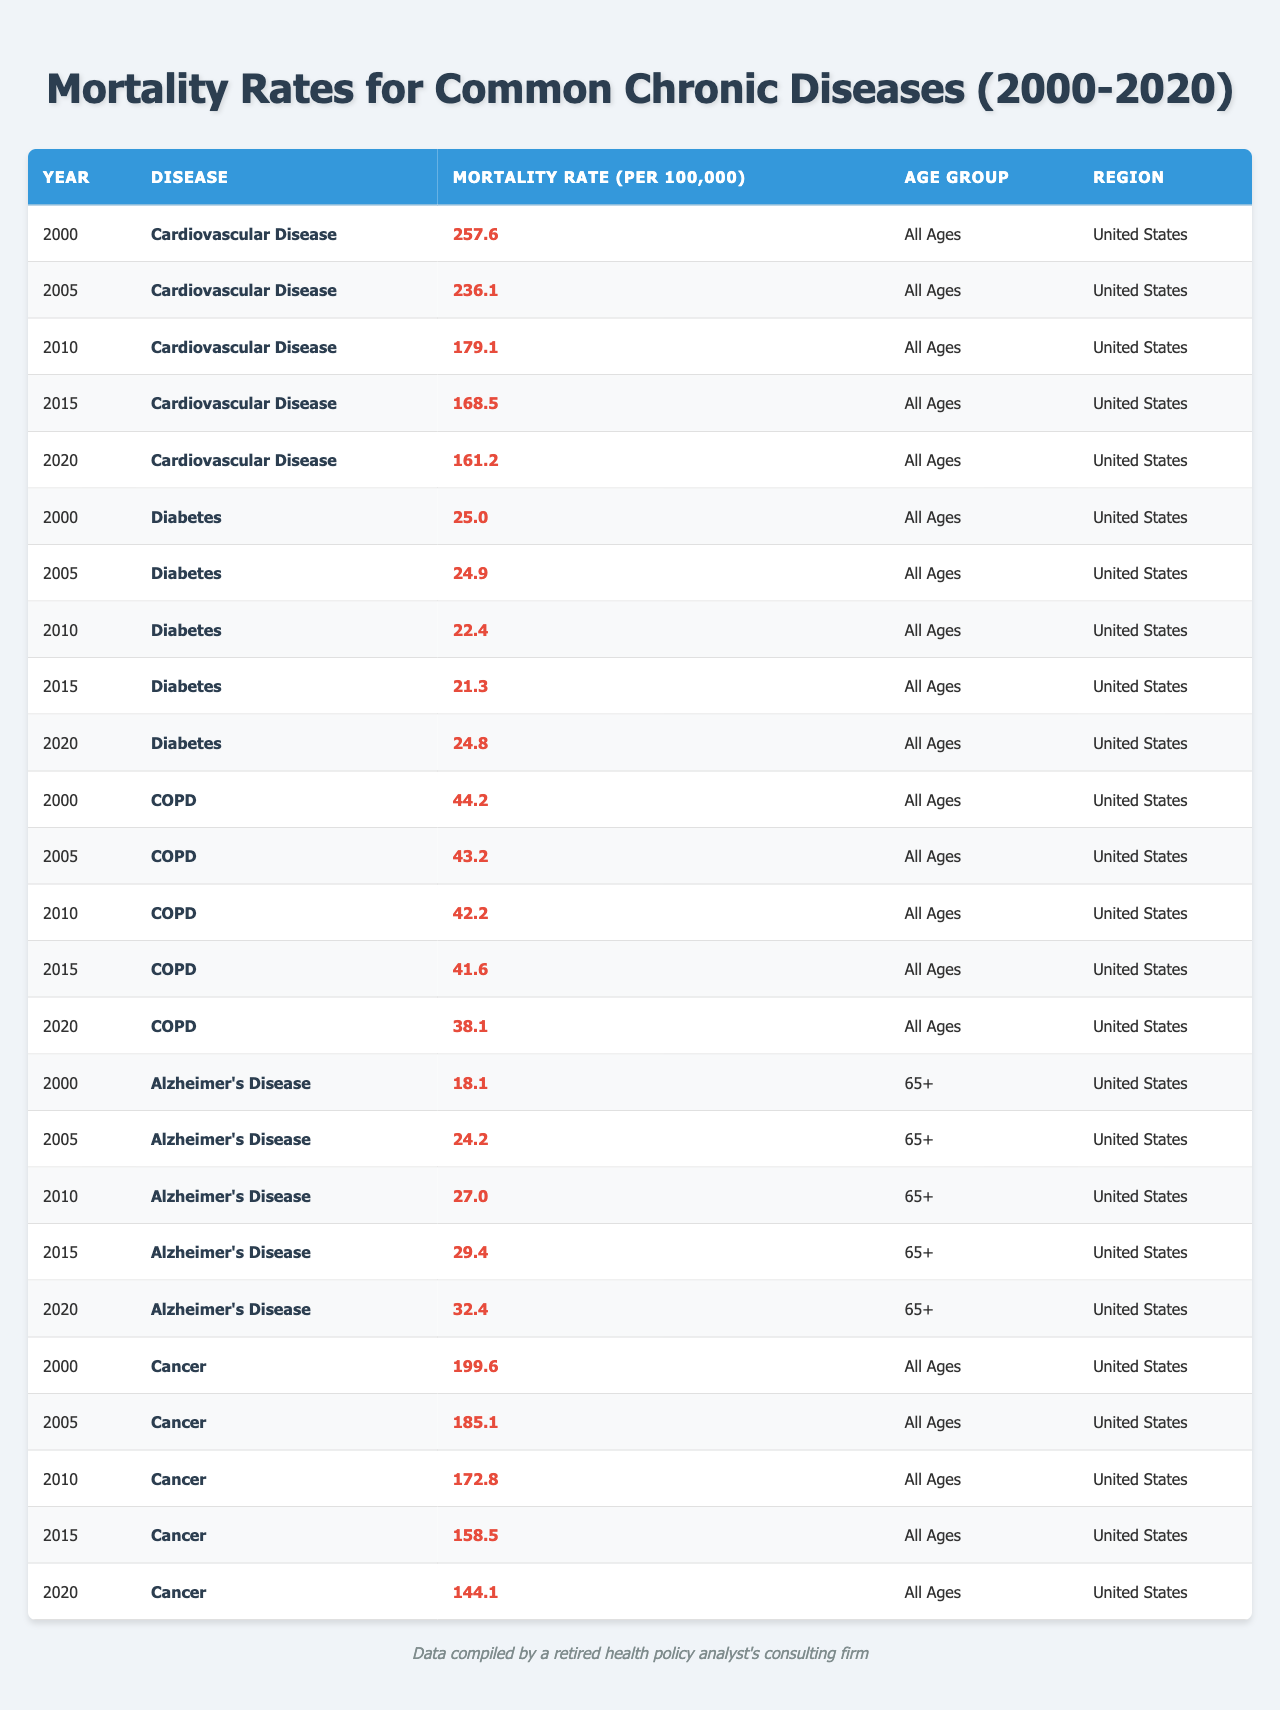What was the mortality rate for Cardiovascular Disease in 2000? The table shows that in 2000, the mortality rate for Cardiovascular Disease was 257.6 per 100,000.
Answer: 257.6 How did the mortality rate for Diabetes change from 2000 to 2010? In 2000, the mortality rate for Diabetes was 25.0 and in 2010 it was 22.4. Therefore, it decreased by 25.0 - 22.4 = 2.6 per 100,000.
Answer: Decreased by 2.6 Which disease had the highest mortality rate in 2015? Referring to the data in 2015, Cardiovascular Disease had the highest mortality rate at 168.5 per 100,000.
Answer: Cardiovascular Disease What was the average mortality rate for Cancer from 2000 to 2020? The mortality rates for Cancer from 2000-2020 are 199.6, 185.1, 172.8, 158.5, and 144.1. Adding these, the total is 960.1, and dividing by 5 gives an average of 192.02 per 100,000.
Answer: 192.02 Did the mortality rate for COPD decrease consistently from 2000 to 2020? The table shows the mortality rates for COPD over the years: 44.2, 43.2, 42.2, 41.6, 38.1. Since each year shows a decrease, yes, it did decrease consistently.
Answer: Yes Which age group showed the highest increase in mortality rate for Alzheimer's Disease from 2005 to 2020? In 2005, the mortality rate for Alzheimer’s Disease was 24.2 and in 2020 it was 32.4. The increase is 32.4 - 24.2 = 8.2 per 100,000. This is the only age group shown for Alzheimer’s Disease, so it is also the highest.
Answer: 8.2 What was the percentage decrease in the mortality rate for Cancer from 2000 to 2020? The mortality rate for Cancer in 2000 was 199.6 and in 2020 it was 144.1. The decrease is 199.6 - 144.1 = 55.5. To find the percentage decrease: (55.5 / 199.6) * 100 = 27.8%.
Answer: 27.8% Which of the chronic diseases had the lowest mortality rate in 2010? Looking at the table for 2010, Diabetes had the lowest mortality rate at 22.4 per 100,000.
Answer: Diabetes From the data, can we infer that the mortality rate for Diabetes increased over the years? The mortality rates for Diabetes between 2000 (25.0), 2005 (24.9), 2010 (22.4), 2015 (21.3), and 2020 (24.8) initially decreased to 2015, then increased in 2020, so it cannot be said to have increased overall over the years.
Answer: No What is the difference in the mortality rates of COPD between 2000 and 2020? In 2000 the mortality rate for COPD was 44.2 and in 2020 it was 38.1. The difference is 44.2 - 38.1 = 6.1 per 100,000.
Answer: 6.1 